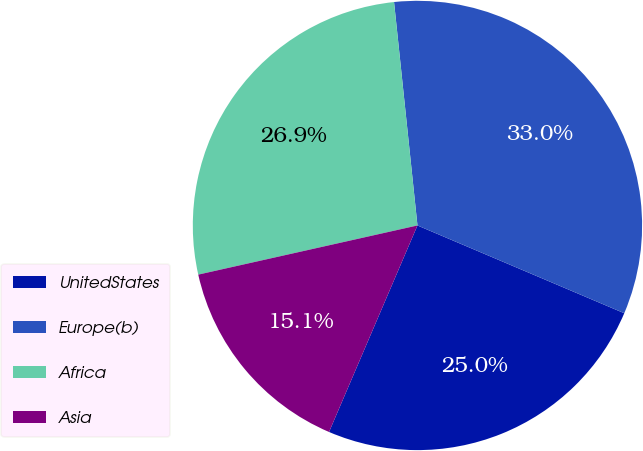<chart> <loc_0><loc_0><loc_500><loc_500><pie_chart><fcel>UnitedStates<fcel>Europe(b)<fcel>Africa<fcel>Asia<nl><fcel>25.05%<fcel>33.05%<fcel>26.85%<fcel>15.05%<nl></chart> 